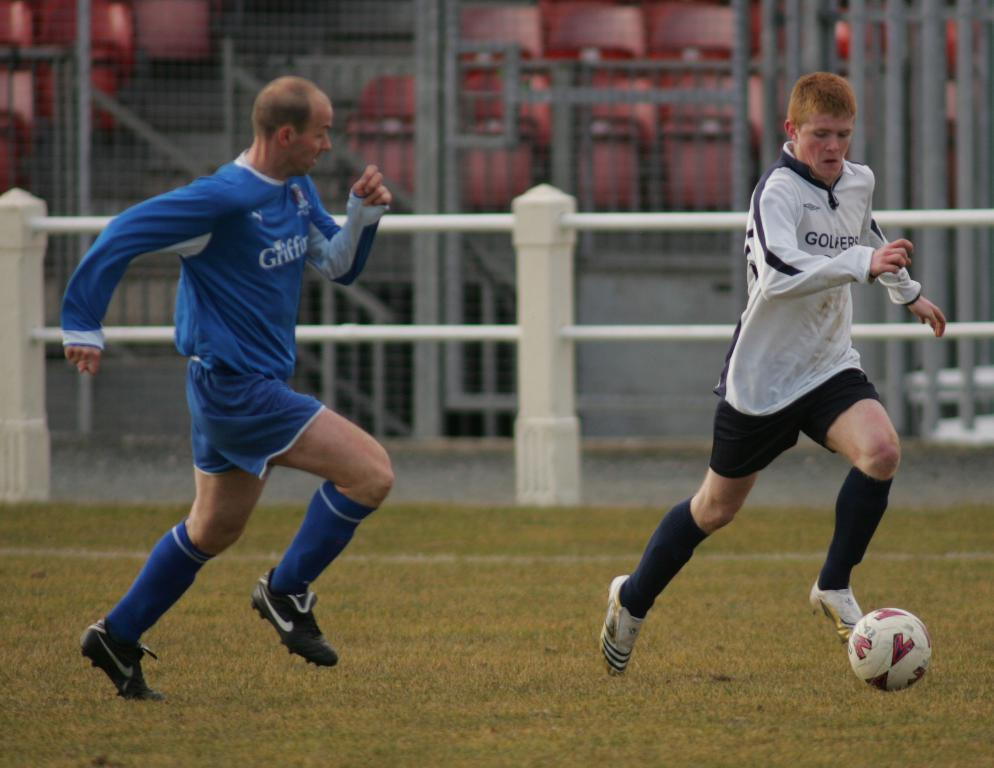How many people are in the image? There are two persons in the image. What are the two persons doing in the image? The two persons are playing on a ground. What can be seen in the background of the image? There is a fencing with a net in the background of the image. What type of drug is being used by the two persons in the image? There is no indication of any drug use in the image; the two persons are playing on a ground. 